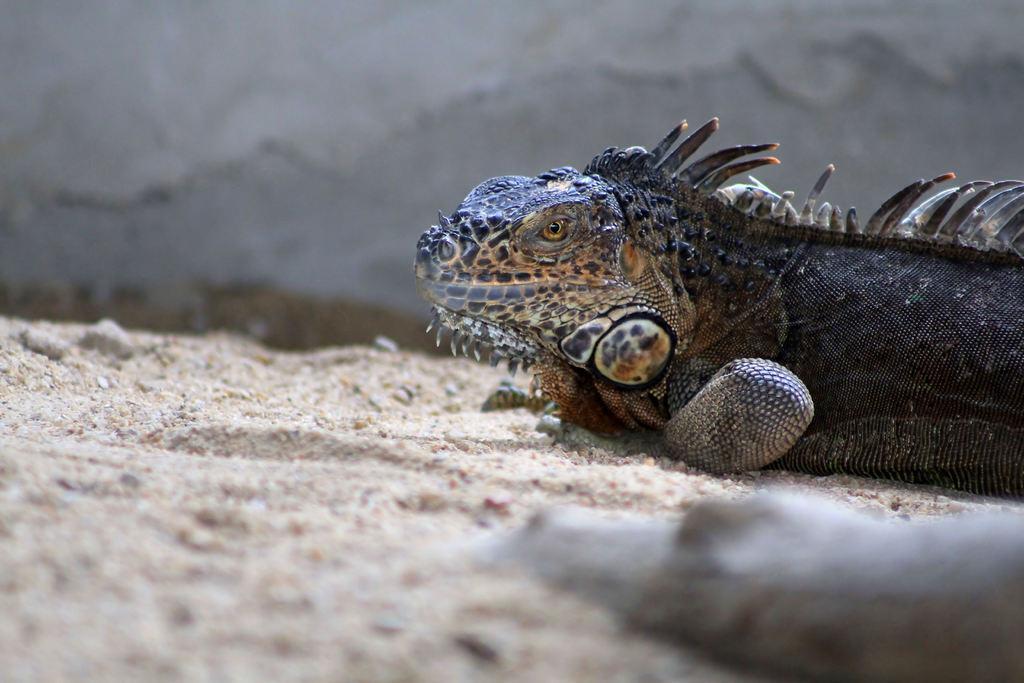Could you give a brief overview of what you see in this image? This picture shows a reptile on the ground. 